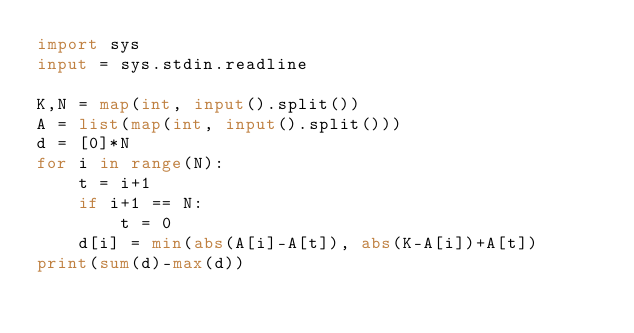Convert code to text. <code><loc_0><loc_0><loc_500><loc_500><_Python_>import sys
input = sys.stdin.readline

K,N = map(int, input().split())
A = list(map(int, input().split()))
d = [0]*N
for i in range(N):
    t = i+1
    if i+1 == N:
        t = 0
    d[i] = min(abs(A[i]-A[t]), abs(K-A[i])+A[t])
print(sum(d)-max(d))</code> 